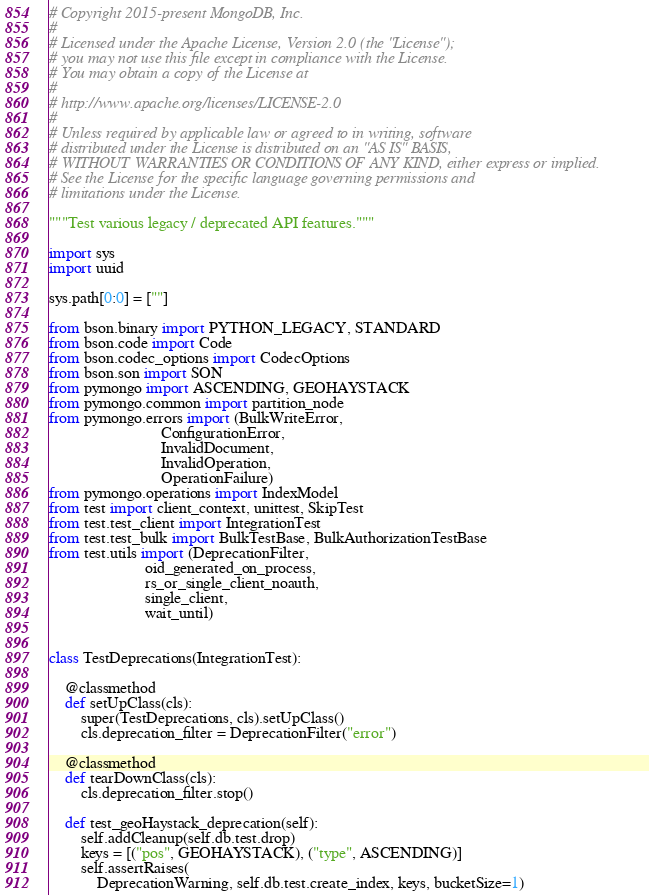<code> <loc_0><loc_0><loc_500><loc_500><_Python_># Copyright 2015-present MongoDB, Inc.
#
# Licensed under the Apache License, Version 2.0 (the "License");
# you may not use this file except in compliance with the License.
# You may obtain a copy of the License at
#
# http://www.apache.org/licenses/LICENSE-2.0
#
# Unless required by applicable law or agreed to in writing, software
# distributed under the License is distributed on an "AS IS" BASIS,
# WITHOUT WARRANTIES OR CONDITIONS OF ANY KIND, either express or implied.
# See the License for the specific language governing permissions and
# limitations under the License.

"""Test various legacy / deprecated API features."""

import sys
import uuid

sys.path[0:0] = [""]

from bson.binary import PYTHON_LEGACY, STANDARD
from bson.code import Code
from bson.codec_options import CodecOptions
from bson.son import SON
from pymongo import ASCENDING, GEOHAYSTACK
from pymongo.common import partition_node
from pymongo.errors import (BulkWriteError,
                            ConfigurationError,
                            InvalidDocument,
                            InvalidOperation,
                            OperationFailure)
from pymongo.operations import IndexModel
from test import client_context, unittest, SkipTest
from test.test_client import IntegrationTest
from test.test_bulk import BulkTestBase, BulkAuthorizationTestBase
from test.utils import (DeprecationFilter,
                        oid_generated_on_process,
                        rs_or_single_client_noauth,
                        single_client,
                        wait_until)


class TestDeprecations(IntegrationTest):

    @classmethod
    def setUpClass(cls):
        super(TestDeprecations, cls).setUpClass()
        cls.deprecation_filter = DeprecationFilter("error")

    @classmethod
    def tearDownClass(cls):
        cls.deprecation_filter.stop()

    def test_geoHaystack_deprecation(self):
        self.addCleanup(self.db.test.drop)
        keys = [("pos", GEOHAYSTACK), ("type", ASCENDING)]
        self.assertRaises(
            DeprecationWarning, self.db.test.create_index, keys, bucketSize=1)</code> 